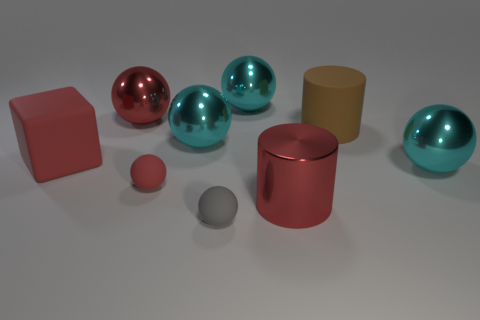Subtract all cyan balls. How many were subtracted if there are1cyan balls left? 2 Subtract all brown blocks. How many red spheres are left? 2 Subtract all tiny red balls. How many balls are left? 5 Subtract all cyan balls. How many balls are left? 3 Subtract 1 balls. How many balls are left? 5 Add 1 big metallic objects. How many objects exist? 10 Subtract all blocks. How many objects are left? 8 Subtract all green spheres. Subtract all green blocks. How many spheres are left? 6 Add 5 cyan things. How many cyan things exist? 8 Subtract 0 yellow cylinders. How many objects are left? 9 